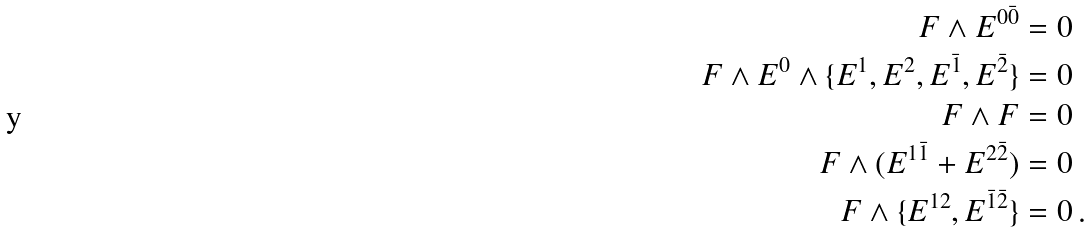Convert formula to latex. <formula><loc_0><loc_0><loc_500><loc_500>F \wedge { E } ^ { 0 \bar { 0 } } & = 0 \\ F \wedge { E } ^ { 0 } \wedge \{ { E } ^ { 1 } , { E } ^ { 2 } , { E } ^ { \bar { 1 } } , { E } ^ { \bar { 2 } } \} & = 0 \\ F \wedge F & = 0 \\ F \wedge ( { E } ^ { 1 \bar { 1 } } + { E } ^ { 2 \bar { 2 } } ) & = 0 \\ F \wedge \{ { E } ^ { 1 2 } , { E } ^ { { \bar { 1 } } { \bar { 2 } } } \} & = 0 \, .</formula> 